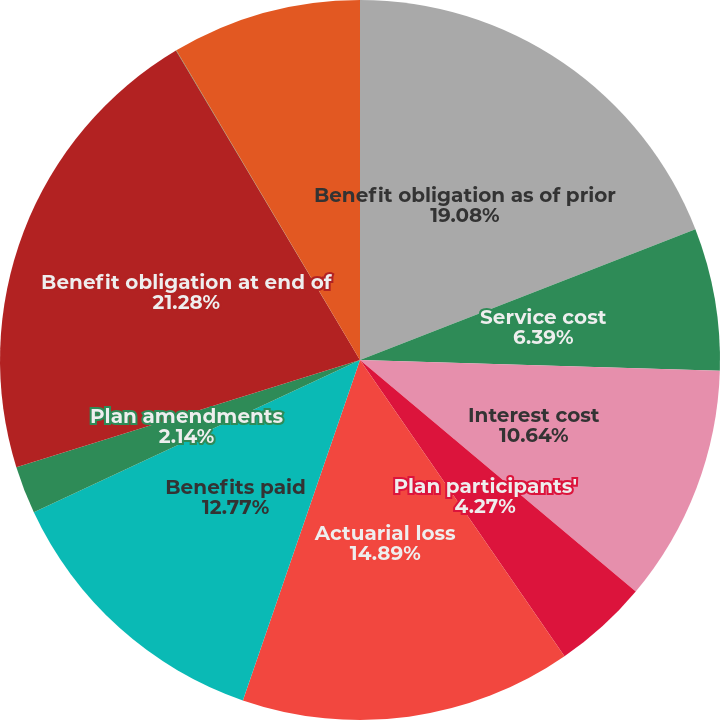Convert chart. <chart><loc_0><loc_0><loc_500><loc_500><pie_chart><fcel>Benefit obligation as of prior<fcel>Service cost<fcel>Interest cost<fcel>Plan participants'<fcel>Actuarial loss<fcel>Benefits paid<fcel>Plan amendments<fcel>Benefit obligation at end of<fcel>Fair value of plan assets at<fcel>Employer contributions<nl><fcel>19.08%<fcel>6.39%<fcel>10.64%<fcel>4.27%<fcel>14.89%<fcel>12.77%<fcel>2.14%<fcel>21.27%<fcel>0.02%<fcel>8.52%<nl></chart> 